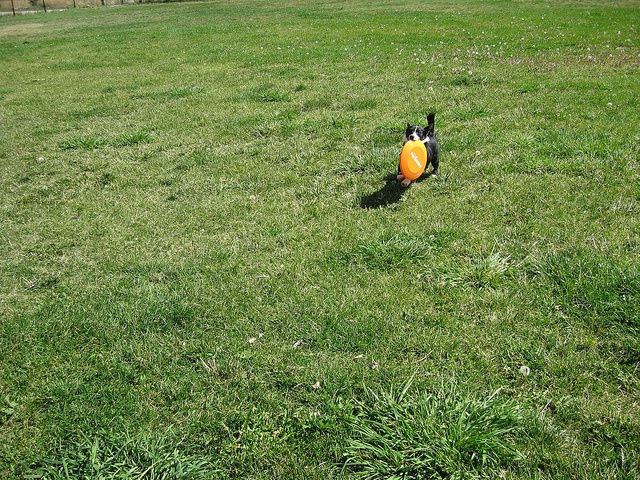Describe the objects in this image and their specific colors. I can see dog in gray, black, orange, and gold tones and frisbee in gray, orange, and gold tones in this image. 